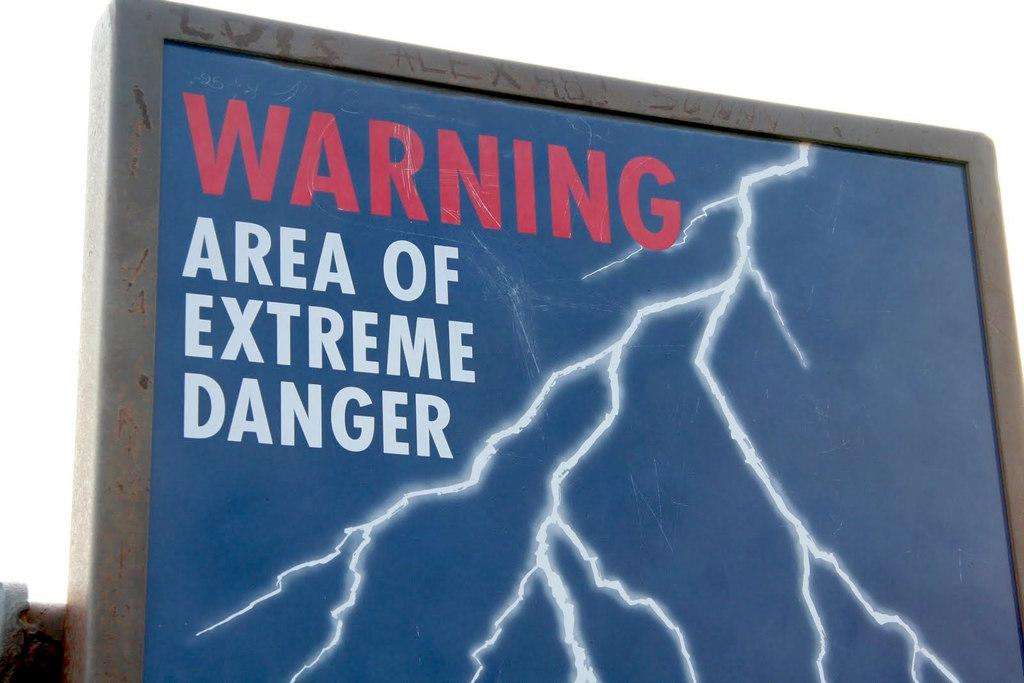<image>
Offer a succinct explanation of the picture presented. A sign with a lightening bolt is a warning that this is an area of extreme danger. 